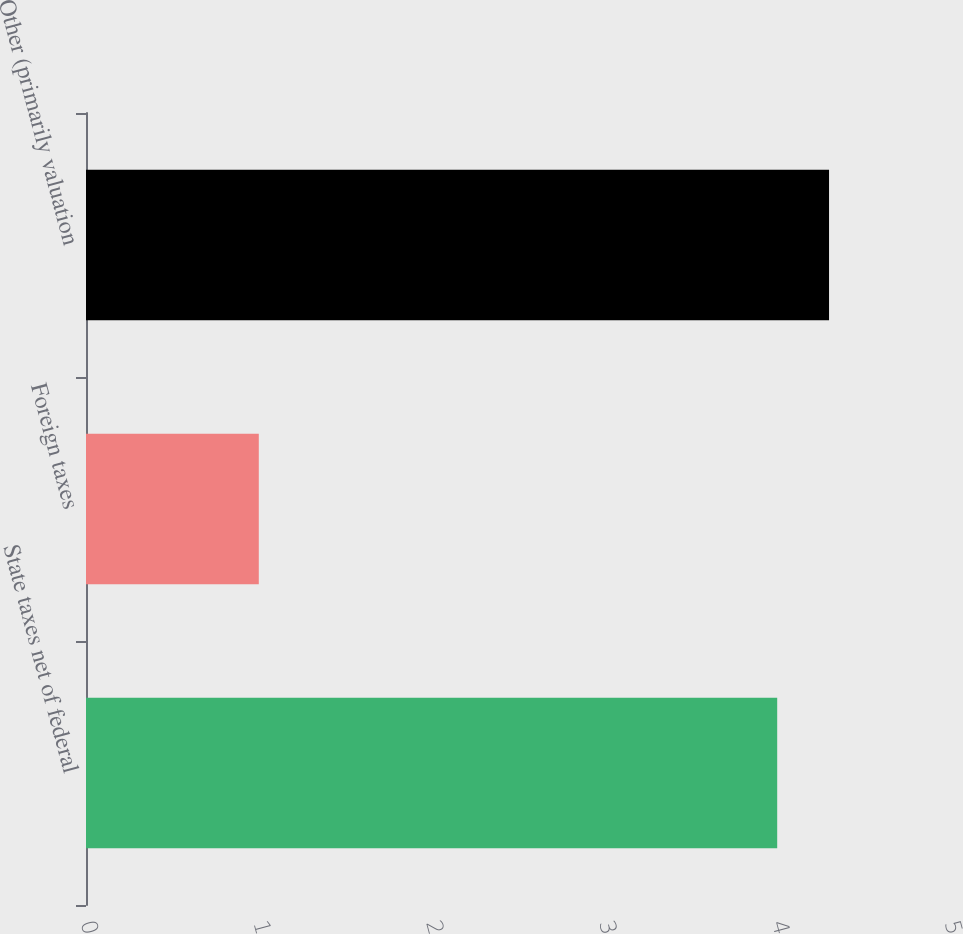Convert chart to OTSL. <chart><loc_0><loc_0><loc_500><loc_500><bar_chart><fcel>State taxes net of federal<fcel>Foreign taxes<fcel>Other (primarily valuation<nl><fcel>4<fcel>1<fcel>4.3<nl></chart> 